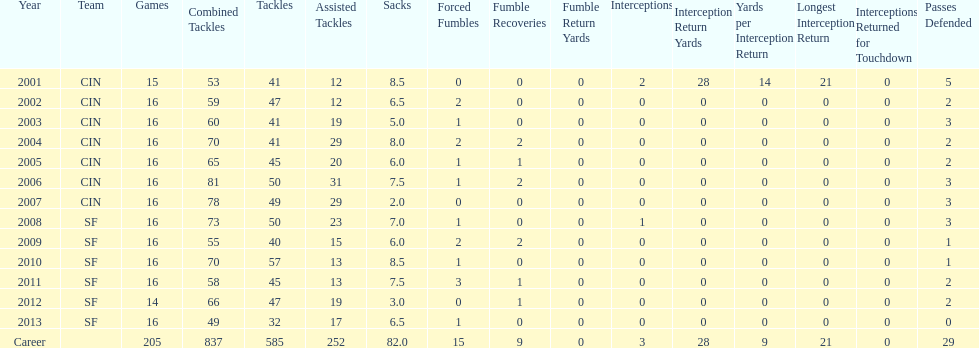What is the only season he has fewer than three sacks? 2007. 